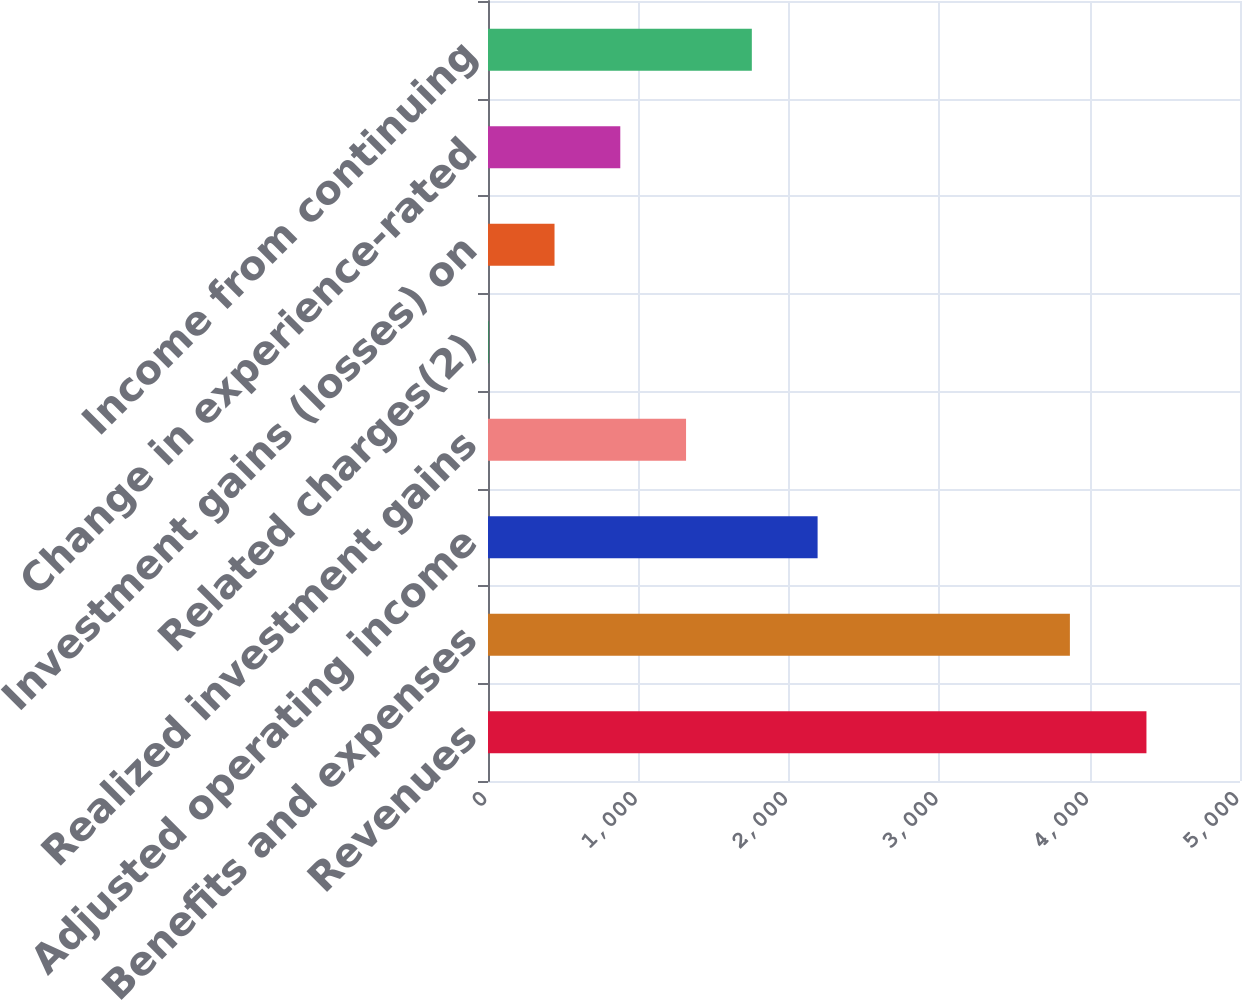Convert chart to OTSL. <chart><loc_0><loc_0><loc_500><loc_500><bar_chart><fcel>Revenues<fcel>Benefits and expenses<fcel>Adjusted operating income<fcel>Realized investment gains<fcel>Related charges(2)<fcel>Investment gains (losses) on<fcel>Change in experience-rated<fcel>Income from continuing<nl><fcel>4378<fcel>3869<fcel>2191.5<fcel>1316.9<fcel>5<fcel>442.3<fcel>879.6<fcel>1754.2<nl></chart> 